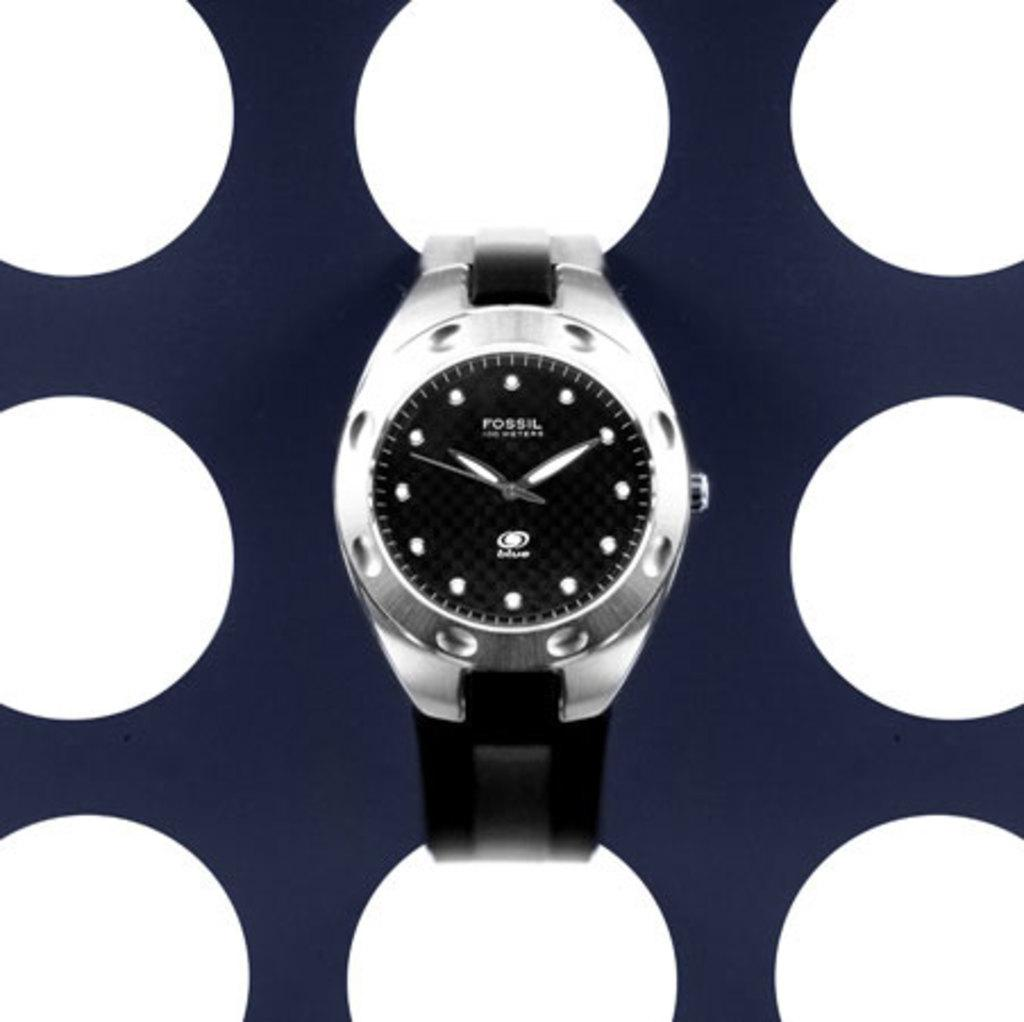<image>
Summarize the visual content of the image. A Fossil branded watch has the time of 10:10 on it. 